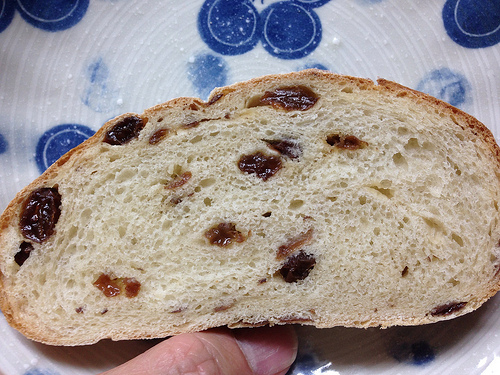<image>
Is there a raisin on the plate? Yes. Looking at the image, I can see the raisin is positioned on top of the plate, with the plate providing support. Is the loaf under the plate? No. The loaf is not positioned under the plate. The vertical relationship between these objects is different. 